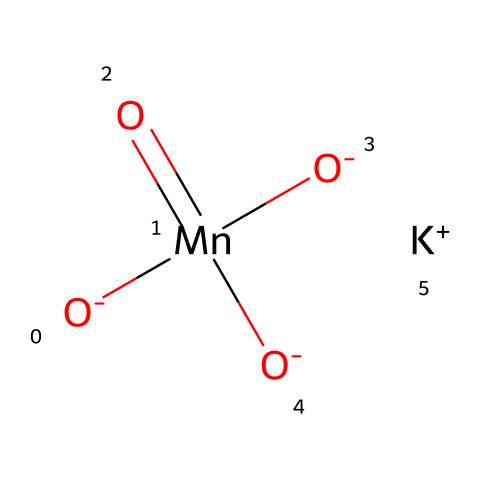What is the total number of oxygen atoms in potassium permanganate? The SMILES representation shows four oxygen atoms connected to the manganese atom and one from the ionic form of the compound. Therefore, the total count is four.
Answer: four How many potassium ions are present in the chemical? The SMILES indicates one potassium ion is bonded with the permanganate ion, denoted by [K+].
Answer: one What is the oxidation state of manganese in potassium permanganate? In the structure, manganese is connected to four oxygen atoms, each with an oxidation state of -2. This results in the manganese needing to be +7 to balance the charge, making the oxidation state +7.
Answer: +7 Which element serves as the central atom in potassium permanganate? The structure clearly shows that manganese is the atom at the center of the molecule, coordinated with the four oxygen atoms.
Answer: manganese How does the geometry of potassium permanganate relate to its oxidizing properties? The tetrahedral molecular geometry around the manganese atom leads to a strong ability to accept electrons from other substances, enhancing its oxidative capability.
Answer: tetrahedral What type of bonding is primarily responsible for the stability of potassium permanganate? The presence of ionic bonding between the potassium ion and the permanganate ion, alongside covalent bonds between manganese and oxygen, provides the stability of the molecule.
Answer: ionic and covalent How does the arrangement of the oxygen atoms influence the reactivity of potassium permanganate? The arrangement of oxygen around manganese allows for effective electron transfer, which is critical for its role as a strong oxidizer in various reactions.
Answer: electron transfer 